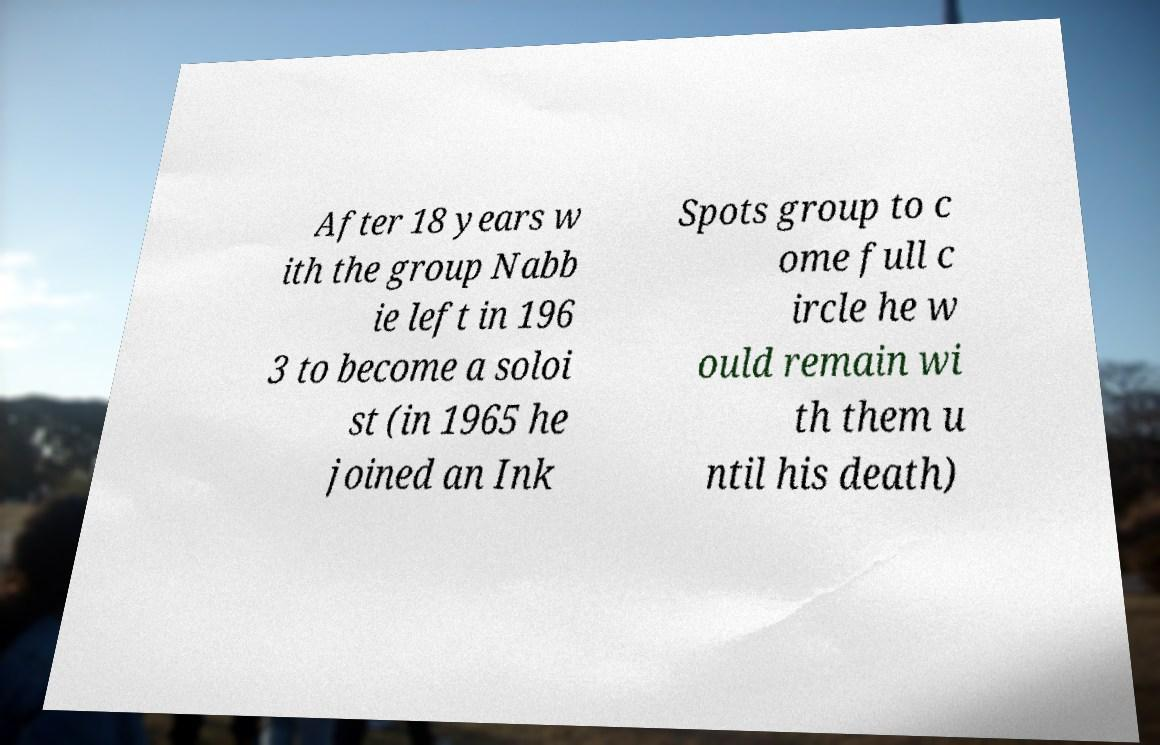What messages or text are displayed in this image? I need them in a readable, typed format. After 18 years w ith the group Nabb ie left in 196 3 to become a soloi st (in 1965 he joined an Ink Spots group to c ome full c ircle he w ould remain wi th them u ntil his death) 